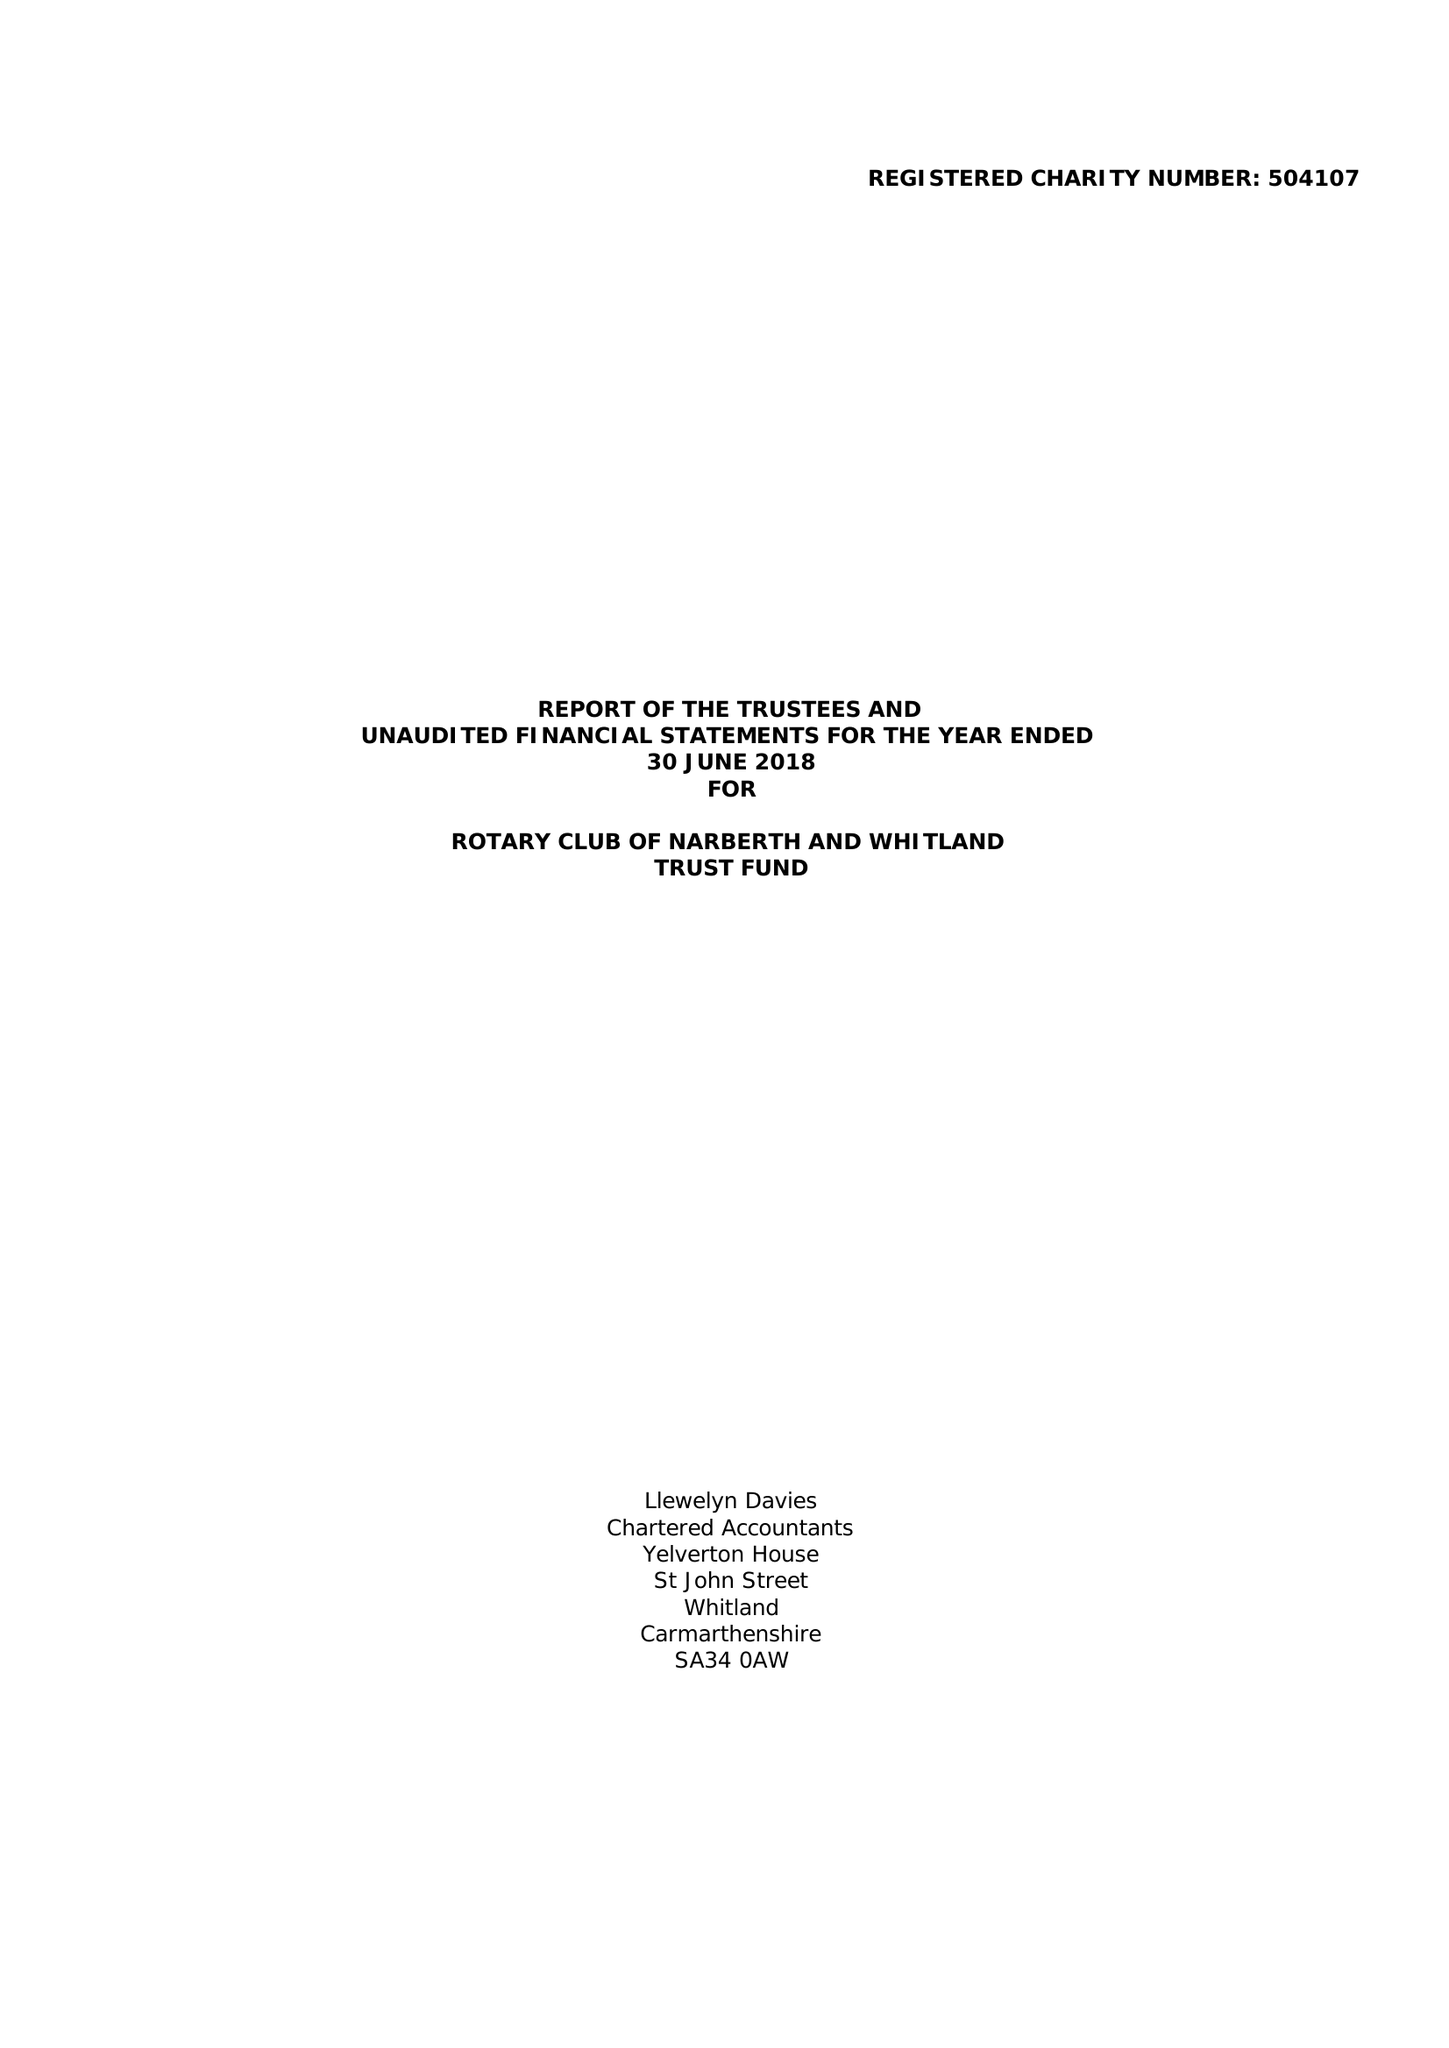What is the value for the charity_number?
Answer the question using a single word or phrase. 504107 